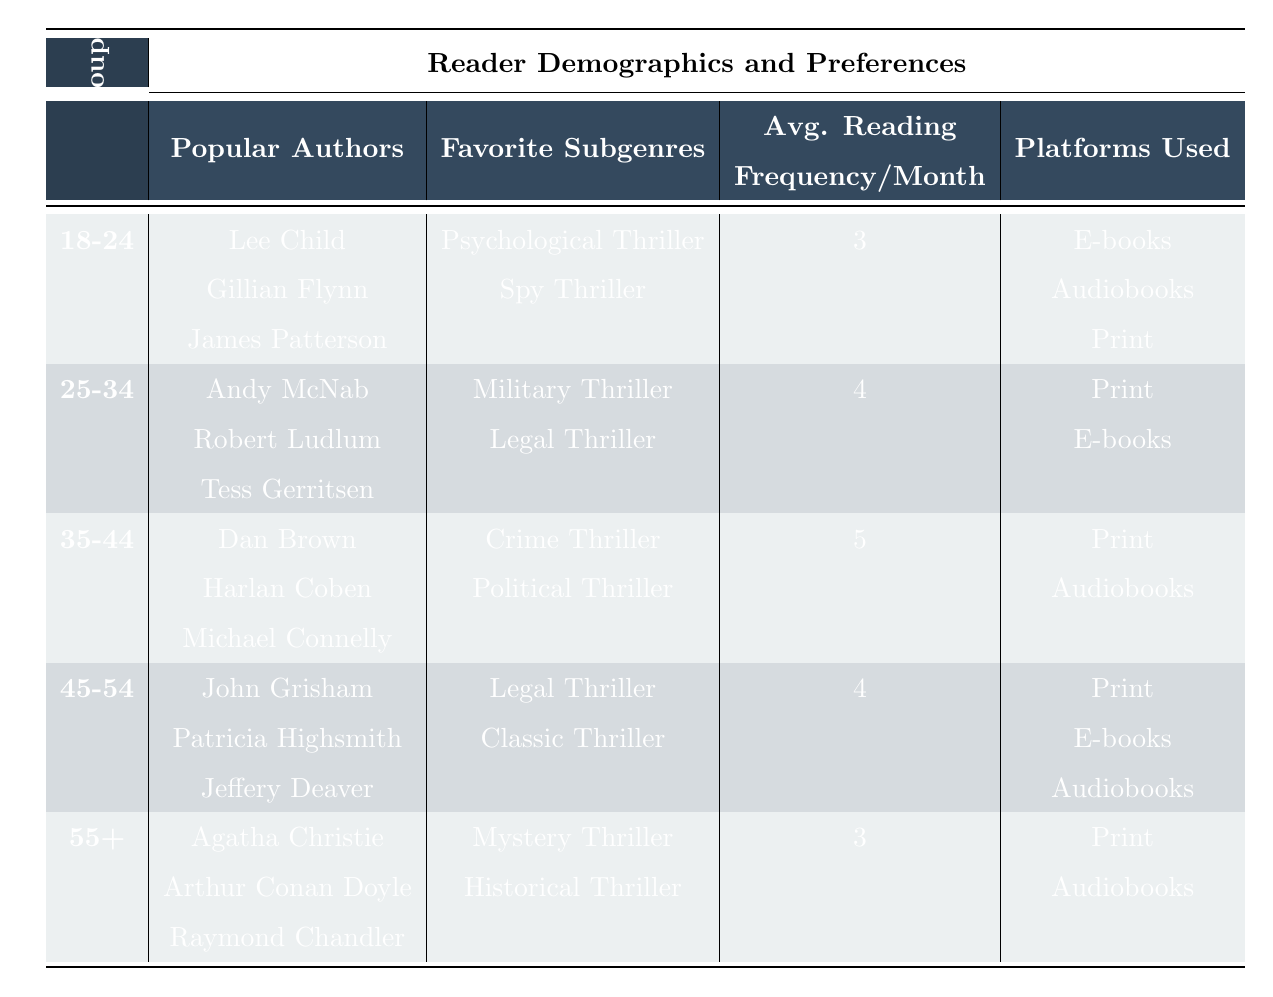What are the popular authors for the age group 25-34? In the table, under the age group 25-34, the popular authors listed are Andy McNab, Robert Ludlum, and Tess Gerritsen.
Answer: Andy McNab, Robert Ludlum, Tess Gerritsen Which age group has the highest average reading frequency per month? Looking at the average reading frequency per month, the age group 35-44 has the highest value of 5, while other age groups have values of 3 or 4.
Answer: 35-44 True or False: The favorite subgenres of the 18-24 age group include Legal Thriller. By checking the favorite subgenres for the 18-24 age group in the table, we see they include Psychological Thriller and Spy Thriller, but not Legal Thriller. Thus, the statement is false.
Answer: False What is the difference in average reading frequency between the 35-44 and 55+ age groups? The average reading frequency for the 35-44 age group is 5, and for the 55+ group, it is 3. The difference is 5 - 3 = 2.
Answer: 2 Which platforms are used by the 45-54 age group to read thrillers? The table shows that the platforms used by the 45-54 age group are Print, E-books, and Audiobooks.
Answer: Print, E-books, Audiobooks What are the popular authors for the youngest age group, and how do they differ from the oldest age group? The popular authors for the 18-24 age group are Lee Child, Gillian Flynn, and James Patterson, while for the 55+ age group, they are Agatha Christie, Arthur Conan Doyle, and Raymond Chandler. The authors differ significantly in their time period and style of writing, reflecting the preferences that change with age.
Answer: Lee Child, Gillian Flynn, James Patterson differ from Agatha Christie, Arthur Conan Doyle, Raymond Chandler What is the favorite subgenre for the 35-44 age group, and how does it compare to the favorite subgenre of the 25-34 age group? The favorite subgenres for the 35-44 age group are Crime Thriller and Political Thriller. In contrast, the 25-34 age group's favorites are Military Thriller and Legal Thriller. Both age groups prefer distinct themes, leading to different subgenre preferences.
Answer: Crime Thriller, Political Thriller differ from Military Thriller, Legal Thriller Which age group most often uses e-books and audiobooks? By examining the table, the age group 18-24 uses E-books, Audiobooks, and Print, but the age group 45-54 also uses E-books, Audiobooks, and Print. Therefore, both age groups use these platforms frequently.
Answer: 18-24 and 45-54 